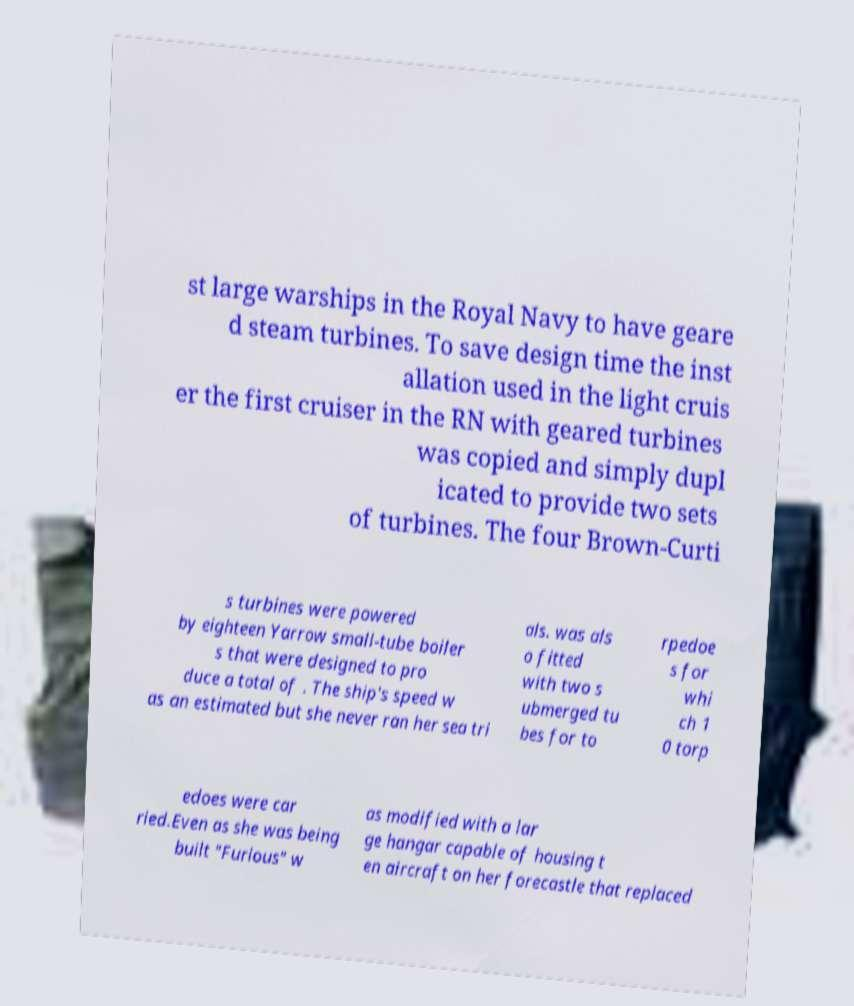Could you extract and type out the text from this image? st large warships in the Royal Navy to have geare d steam turbines. To save design time the inst allation used in the light cruis er the first cruiser in the RN with geared turbines was copied and simply dupl icated to provide two sets of turbines. The four Brown-Curti s turbines were powered by eighteen Yarrow small-tube boiler s that were designed to pro duce a total of . The ship's speed w as an estimated but she never ran her sea tri als. was als o fitted with two s ubmerged tu bes for to rpedoe s for whi ch 1 0 torp edoes were car ried.Even as she was being built "Furious" w as modified with a lar ge hangar capable of housing t en aircraft on her forecastle that replaced 